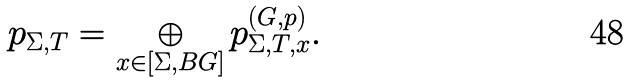Convert formula to latex. <formula><loc_0><loc_0><loc_500><loc_500>p _ { \Sigma , T } = \bigoplus _ { x \in [ \Sigma , B G ] } p ^ { ( G , p ) } _ { \Sigma , T , x } .</formula> 